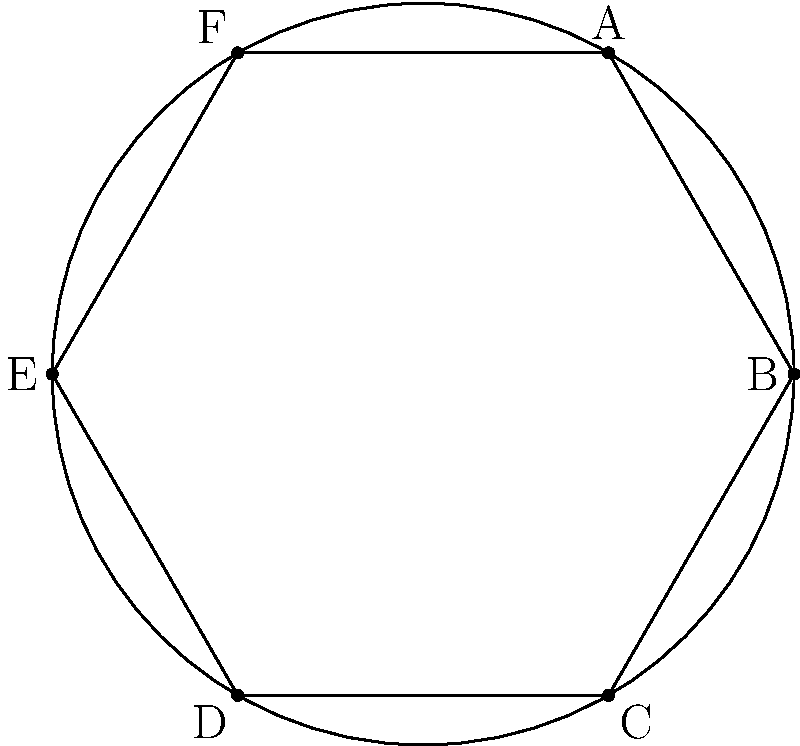On a sphere, you've got a hexagon ABCDEF. What's the sum of its interior angles? Let's break this down:

1. In flat (Euclidean) geometry, the sum of interior angles of a polygon with n sides is (n-2) × 180°.

2. On a sphere (non-Euclidean geometry), this formula doesn't work. The sum is always greater than in flat space.

3. For a sphere, we use this formula: Sum = (n-2) × 180° + A, where A is the area of the polygon on the sphere.

4. The excess (A) depends on how much of the sphere's surface the polygon covers.

5. For a hexagon that covers exactly half a sphere, A would be 360°.

6. In this case, n = 6 (hexagon).

7. Plugging into our formula: Sum = (6-2) × 180° + 360° = 720° + 360° = 1080°

Remember, this is just one possibility. The actual sum depends on how much of the sphere the hexagon covers.
Answer: 1080° 